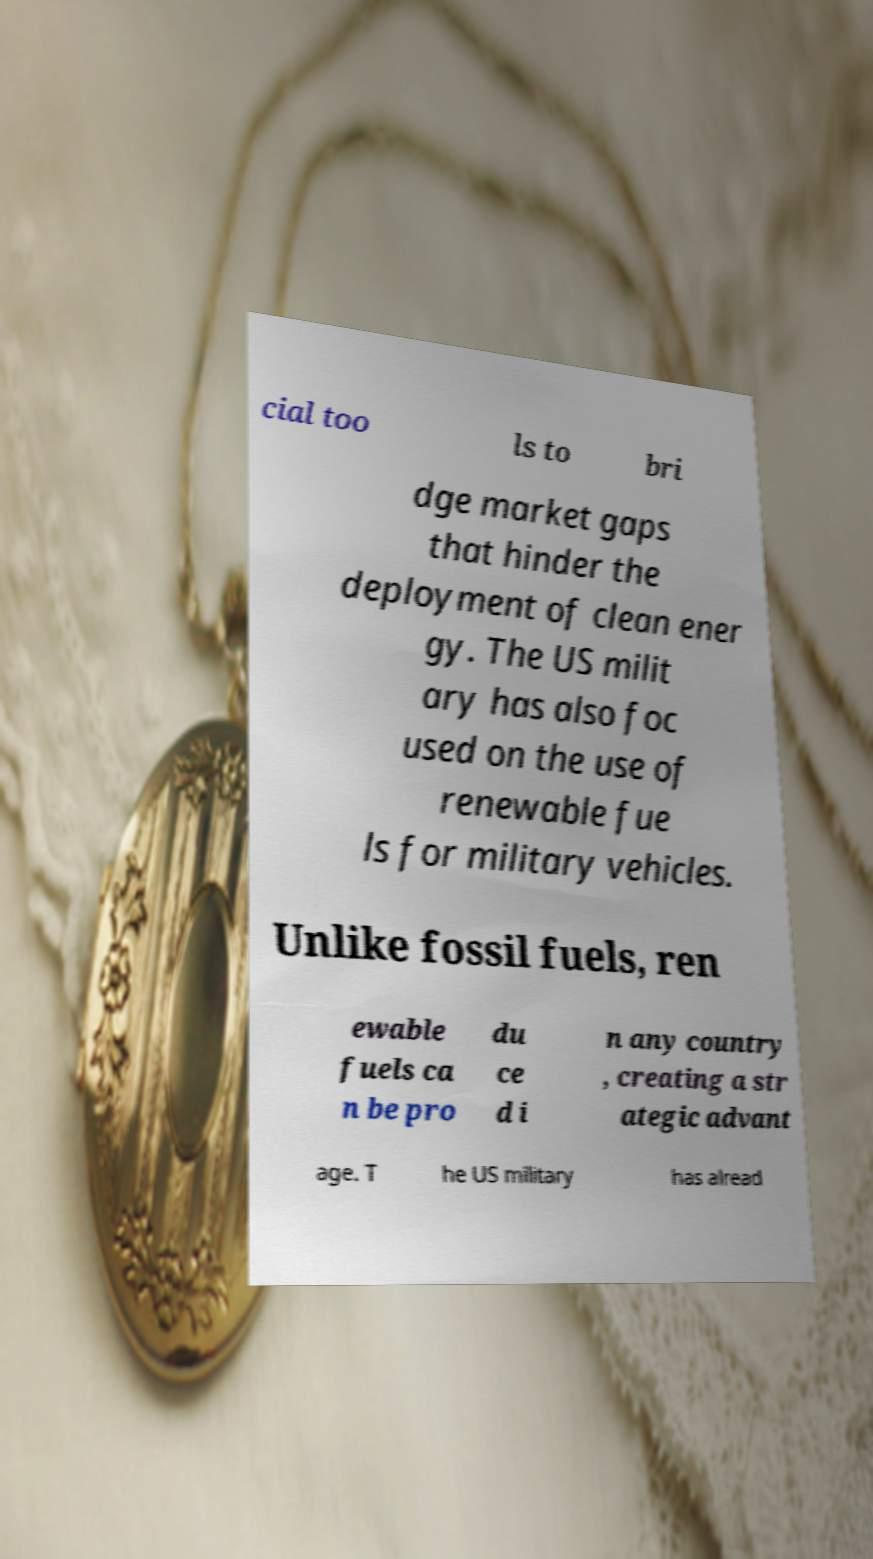For documentation purposes, I need the text within this image transcribed. Could you provide that? cial too ls to bri dge market gaps that hinder the deployment of clean ener gy. The US milit ary has also foc used on the use of renewable fue ls for military vehicles. Unlike fossil fuels, ren ewable fuels ca n be pro du ce d i n any country , creating a str ategic advant age. T he US military has alread 